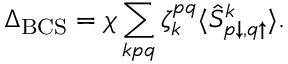Convert formula to latex. <formula><loc_0><loc_0><loc_500><loc_500>\Delta _ { B C S } = \chi \sum _ { k p q } \zeta _ { k } ^ { p q } \langle \hat { S } _ { p \downarrow , q \uparrow } ^ { k } \rangle .</formula> 